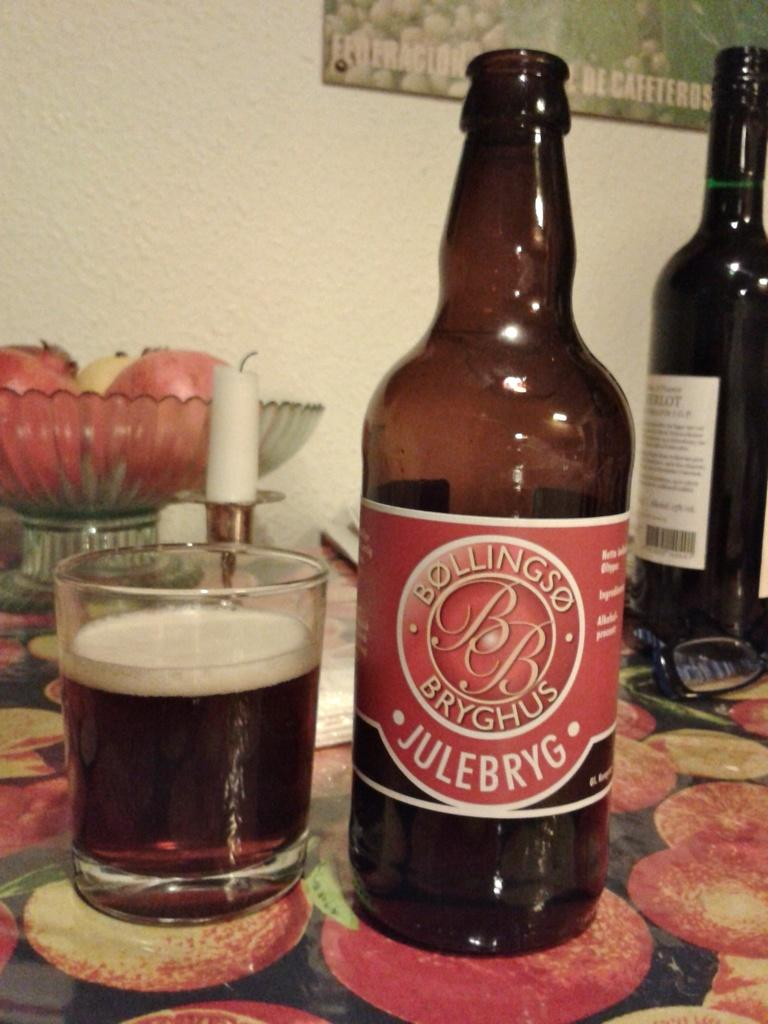<image>
Create a compact narrative representing the image presented. A bottle of Bollings Julebryg beer sits on a table with a fruit 